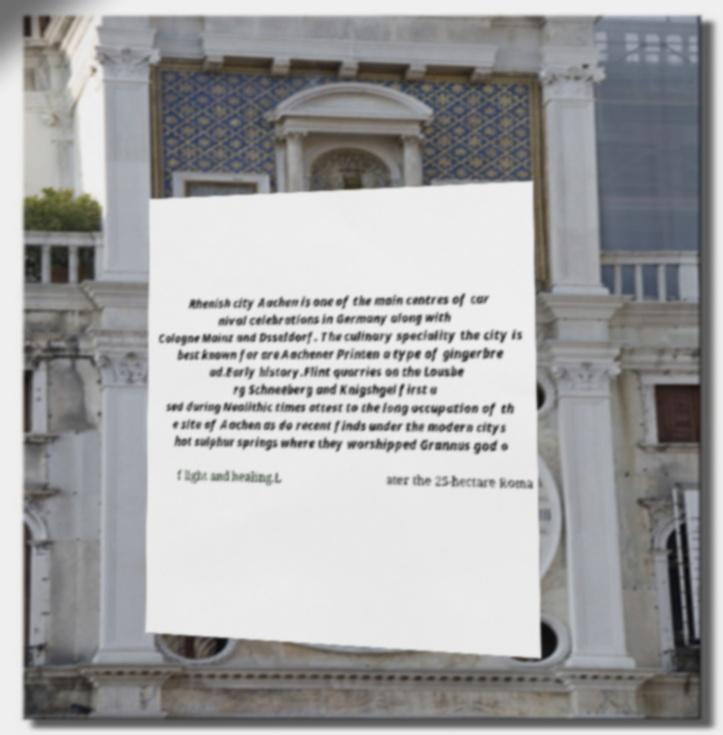Please read and relay the text visible in this image. What does it say? Rhenish city Aachen is one of the main centres of car nival celebrations in Germany along with Cologne Mainz and Dsseldorf. The culinary speciality the city is best known for are Aachener Printen a type of gingerbre ad.Early history.Flint quarries on the Lousbe rg Schneeberg and Knigshgel first u sed during Neolithic times attest to the long occupation of th e site of Aachen as do recent finds under the modern citys hot sulphur springs where they worshipped Grannus god o f light and healing.L ater the 25-hectare Roma 